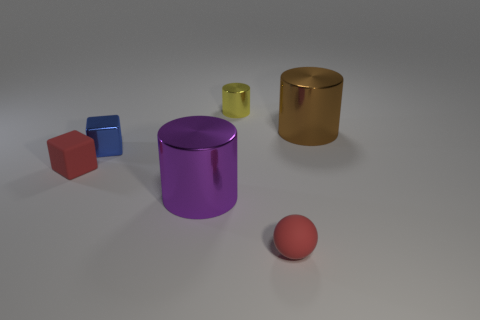Subtract all small cylinders. How many cylinders are left? 2 Subtract 1 cylinders. How many cylinders are left? 2 Subtract all green cubes. How many yellow cylinders are left? 1 Add 2 large gray cubes. How many objects exist? 8 Subtract all brown cylinders. How many cylinders are left? 2 Subtract all cubes. How many objects are left? 4 Subtract all purple cubes. Subtract all brown spheres. How many cubes are left? 2 Subtract all big purple metal spheres. Subtract all small cubes. How many objects are left? 4 Add 3 red objects. How many red objects are left? 5 Add 6 small red things. How many small red things exist? 8 